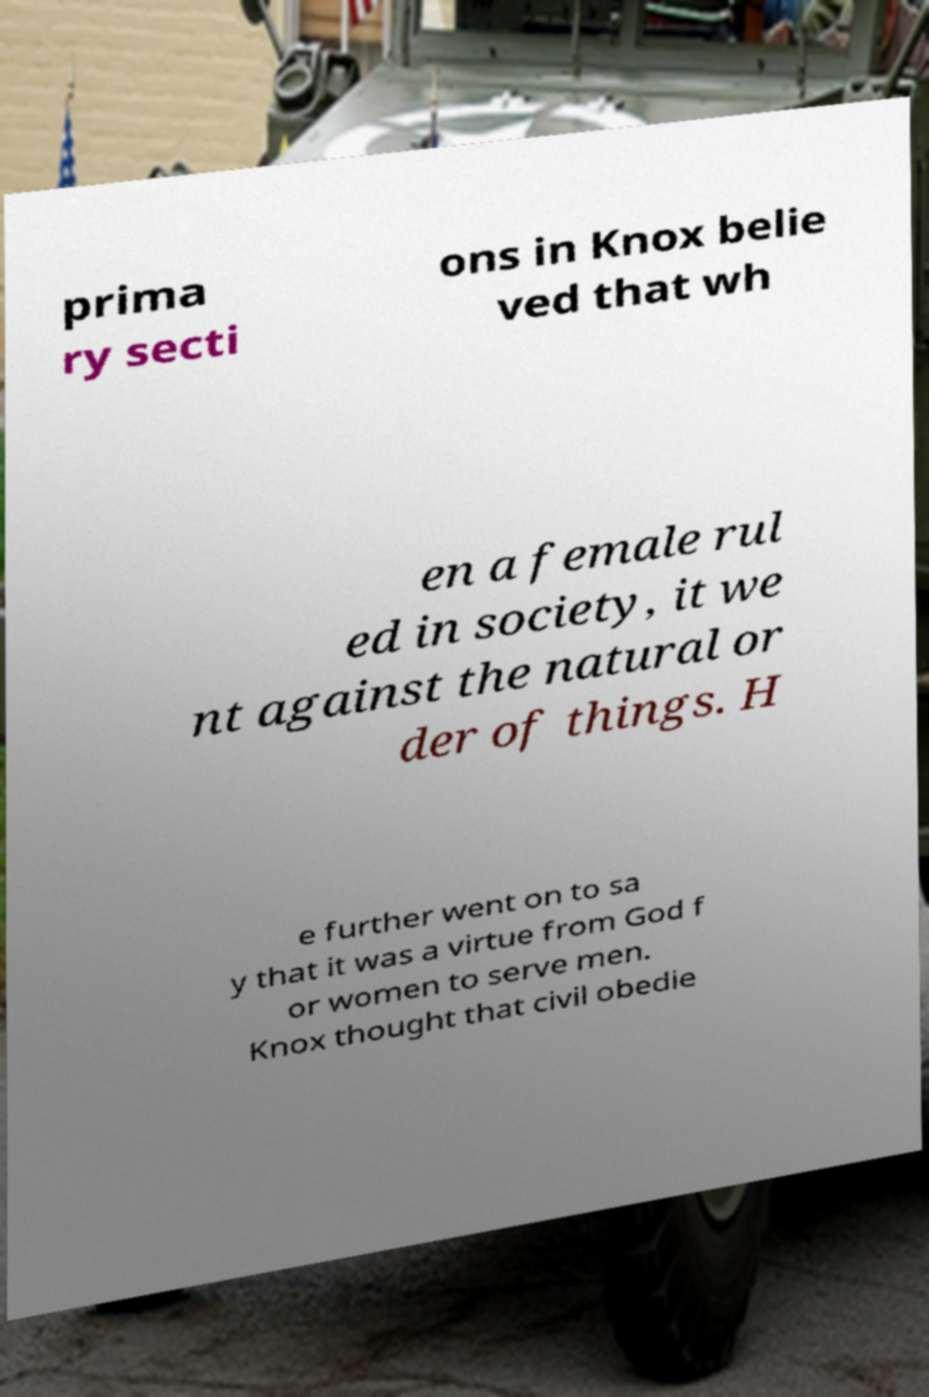There's text embedded in this image that I need extracted. Can you transcribe it verbatim? prima ry secti ons in Knox belie ved that wh en a female rul ed in society, it we nt against the natural or der of things. H e further went on to sa y that it was a virtue from God f or women to serve men. Knox thought that civil obedie 